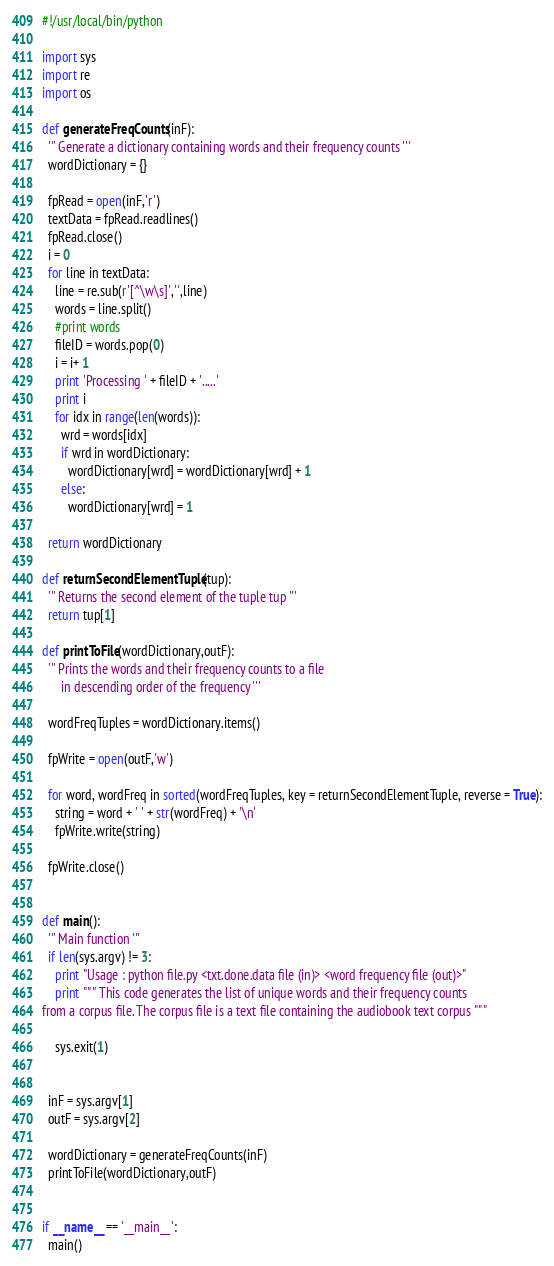<code> <loc_0><loc_0><loc_500><loc_500><_Python_>#!/usr/local/bin/python

import sys
import re
import os

def generateFreqCounts(inF):
  ''' Generate a dictionary containing words and their frequency counts '''
  wordDictionary = {}

  fpRead = open(inF,'r')
  textData = fpRead.readlines()
  fpRead.close()
  i = 0 
  for line in textData:
    line = re.sub(r'[^\w\s]','',line)
    words = line.split()
    #print words
    fileID = words.pop(0)
    i = i+ 1
    print 'Processing ' + fileID + '.....'
    print i
    for idx in range(len(words)):
      wrd = words[idx]
      if wrd in wordDictionary:
        wordDictionary[wrd] = wordDictionary[wrd] + 1
      else:
        wordDictionary[wrd] = 1

  return wordDictionary

def returnSecondElementTuple(tup):
  ''' Returns the second element of the tuple tup '''
  return tup[1]

def printToFile(wordDictionary,outF):
  ''' Prints the words and their frequency counts to a file
      in descending order of the frequency '''

  wordFreqTuples = wordDictionary.items()

  fpWrite = open(outF,'w')
  
  for word, wordFreq in sorted(wordFreqTuples, key = returnSecondElementTuple, reverse = True):
    string = word + ' ' + str(wordFreq) + '\n'
    fpWrite.write(string)

  fpWrite.close()


def main():
  ''' Main function '''
  if len(sys.argv) != 3:
    print "Usage : python file.py <txt.done.data file (in)> <word frequency file (out)>"
    print """ This code generates the list of unique words and their frequency counts 
from a corpus file. The corpus file is a text file containing the audiobook text corpus """

    sys.exit(1)
  

  inF = sys.argv[1]
  outF = sys.argv[2]

  wordDictionary = generateFreqCounts(inF)
  printToFile(wordDictionary,outF)


if __name__ == '__main__':
  main()
</code> 